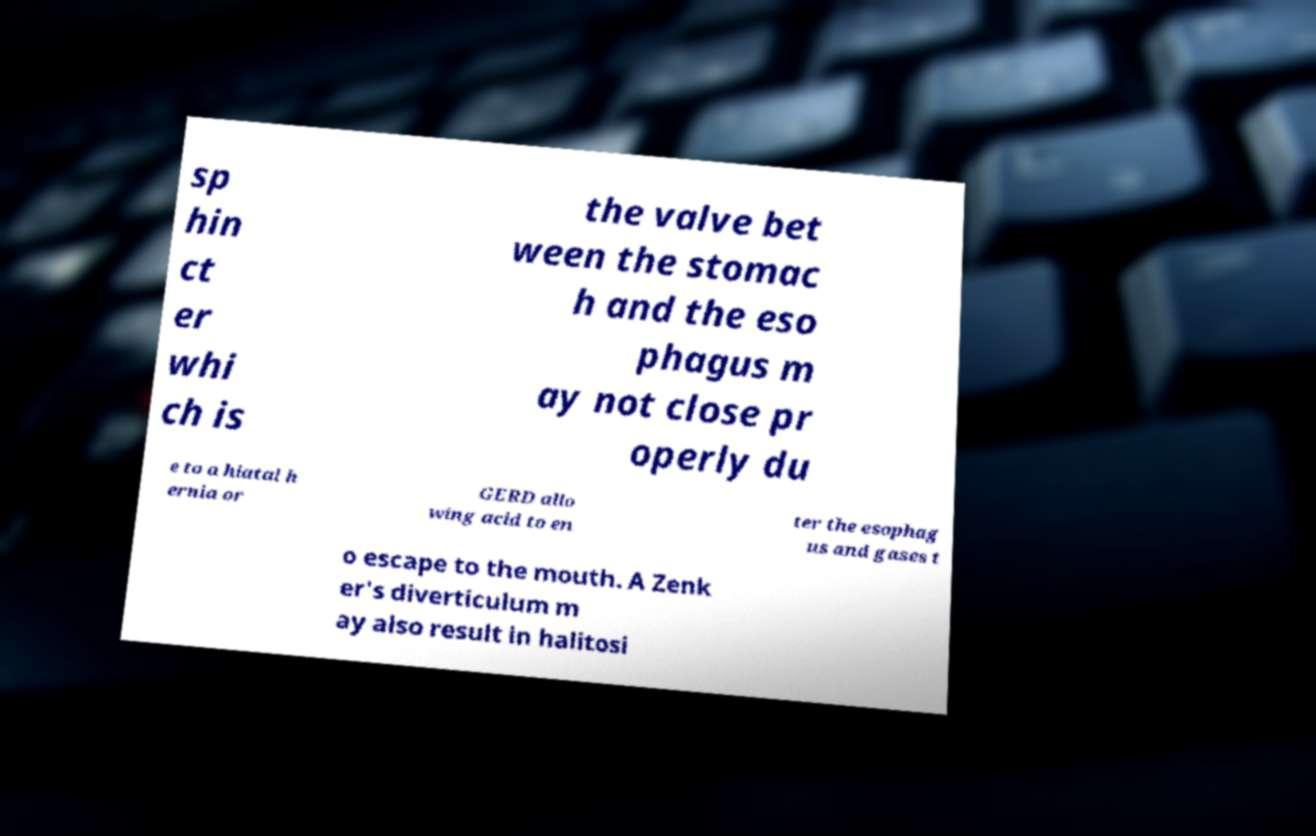I need the written content from this picture converted into text. Can you do that? sp hin ct er whi ch is the valve bet ween the stomac h and the eso phagus m ay not close pr operly du e to a hiatal h ernia or GERD allo wing acid to en ter the esophag us and gases t o escape to the mouth. A Zenk er's diverticulum m ay also result in halitosi 